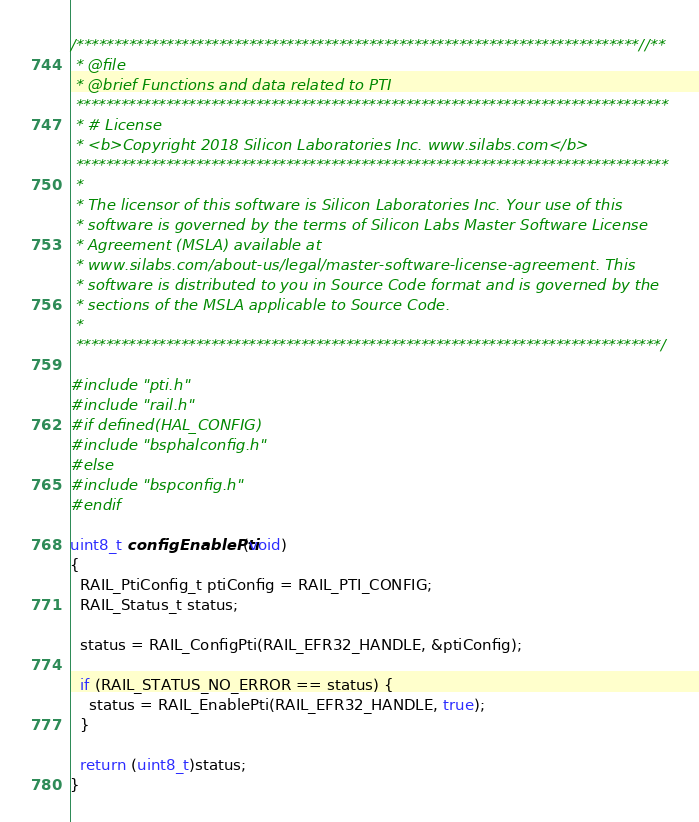Convert code to text. <code><loc_0><loc_0><loc_500><loc_500><_C_>/***************************************************************************//**
 * @file
 * @brief Functions and data related to PTI
 *******************************************************************************
 * # License
 * <b>Copyright 2018 Silicon Laboratories Inc. www.silabs.com</b>
 *******************************************************************************
 *
 * The licensor of this software is Silicon Laboratories Inc. Your use of this
 * software is governed by the terms of Silicon Labs Master Software License
 * Agreement (MSLA) available at
 * www.silabs.com/about-us/legal/master-software-license-agreement. This
 * software is distributed to you in Source Code format and is governed by the
 * sections of the MSLA applicable to Source Code.
 *
 ******************************************************************************/

#include "pti.h"
#include "rail.h"
#if defined(HAL_CONFIG)
#include "bsphalconfig.h"
#else
#include "bspconfig.h"
#endif

uint8_t configEnablePti(void)
{
  RAIL_PtiConfig_t ptiConfig = RAIL_PTI_CONFIG;
  RAIL_Status_t status;

  status = RAIL_ConfigPti(RAIL_EFR32_HANDLE, &ptiConfig);

  if (RAIL_STATUS_NO_ERROR == status) {
    status = RAIL_EnablePti(RAIL_EFR32_HANDLE, true);
  }

  return (uint8_t)status;
}
</code> 